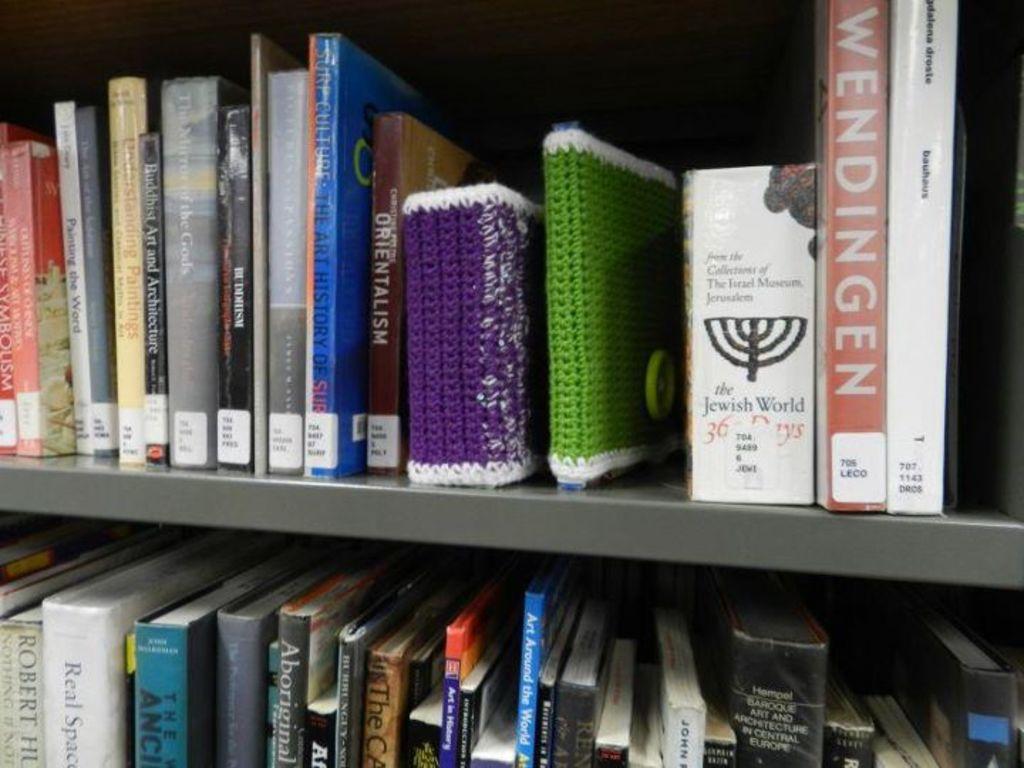What is the right book title?
Your answer should be compact. Wendingen. 